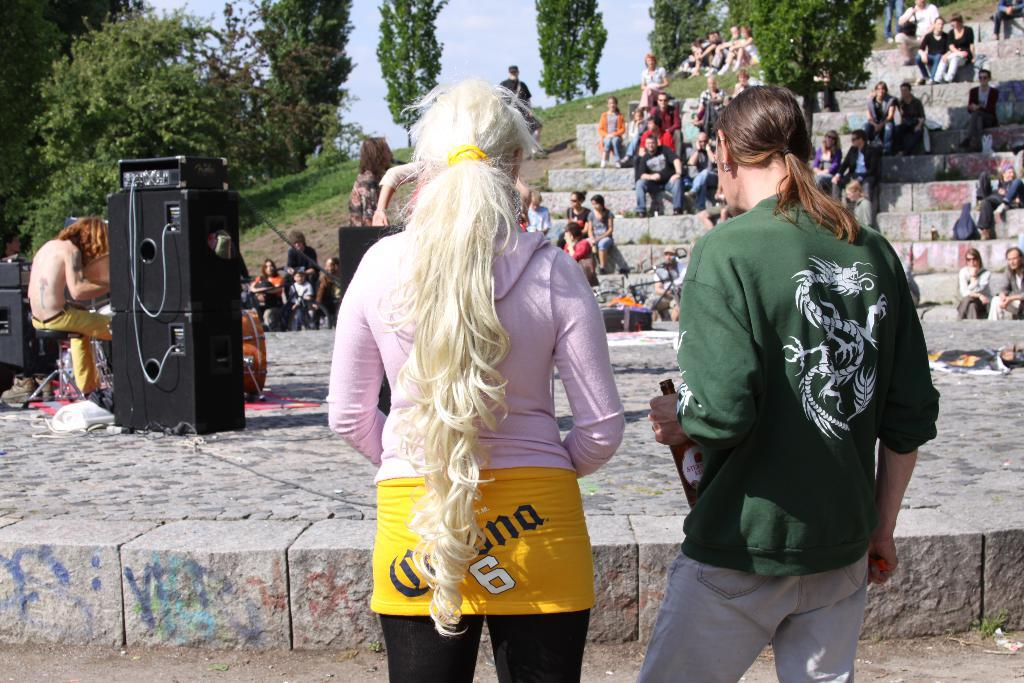How many people are in the image? There are people in the image, but the exact number is not specified. What is one person doing in the image? One person is playing a musical instrument in the image. What can be used for amplifying sound in the image? There are speakers in the image for amplifying sound. What type of vegetation is present in the image? There are trees and grass in the image. What architectural feature can be seen in the image? There are stairs in the image. What other objects can be seen in the image? There are other objects present in the image, but their specific nature is not mentioned. What season is depicted in the image? The provided facts do not mention any seasonal details, so it cannot be determined from the image. Can you see the moon in the image? There is no mention of the moon in the image, so it cannot be seen. Is there a cub playing with the people in the image? There is no mention of a cub or any animal in the image, so it is not present. 